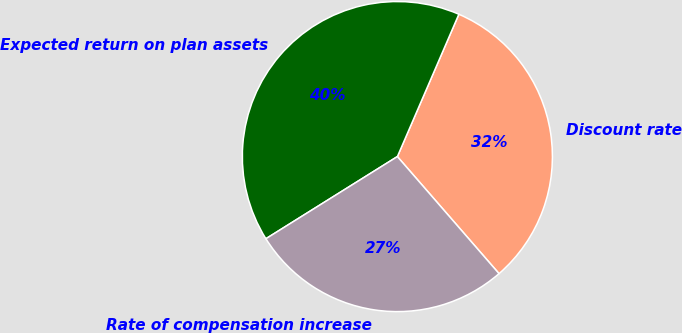Convert chart. <chart><loc_0><loc_0><loc_500><loc_500><pie_chart><fcel>Discount rate<fcel>Expected return on plan assets<fcel>Rate of compensation increase<nl><fcel>32.13%<fcel>40.38%<fcel>27.49%<nl></chart> 